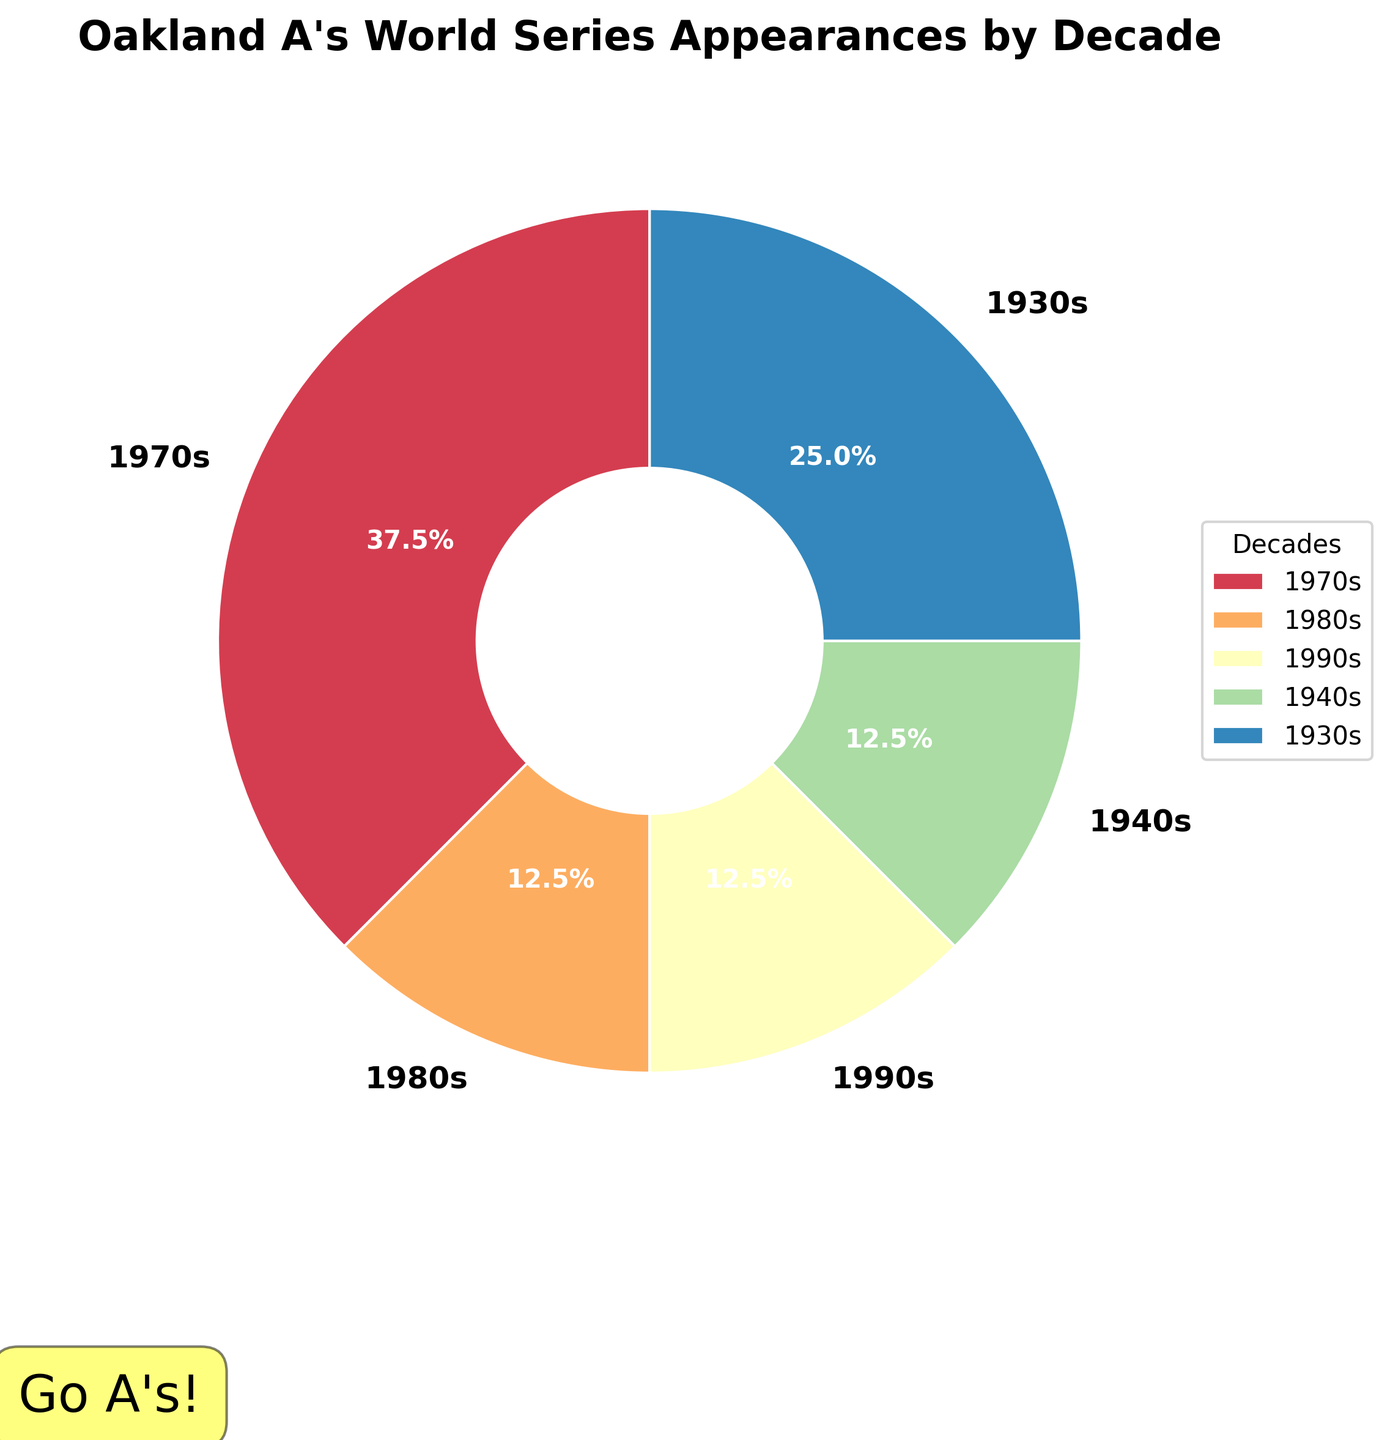Which decade had the highest number of World Series appearances? From the figure, the 1970s segment of the pie chart is the largest, indicating it had the highest number of appearances.
Answer: 1970s How many decades had zero World Series appearances? By looking at the labels, the chart only includes segments corresponding to decades with non-zero appearances. This means there are no segments for the 2000s, 2010s, 1960s, 1950s, 1920s, which are five decades.
Answer: 5 What percentage of the World Series appearances occurred in the 1970s? The pie chart shows the percentage values for each segment. The segment for the 1970s shows 42.9%, which means 42.9% of the World Series appearances occurred in the 1970s.
Answer: 42.9% Compare the number of World Series appearances in the 1930s to those in the 1940s. Which had more? From the chart, the 1930s had 2 appearances, while the 1940s had 1 appearance. Therefore, the 1930s had more appearances.
Answer: 1930s Which decade has the smallest segment in the chart? The smallest segment in the pie chart refers to the 1980s and 1990s, as they each only had 1 appearance. Visually, both segments are the same size, making them the smallest.
Answer: 1980s or 1990s What percentage of the appearances happened before the 1940s? Pre-1940s decades featured here are the 1930s with 2 appearances. The total appearances shown in the chart are 8 (sum of all segments: 3 + 1 + 1 + 1 + 2). The 1930s' 2 appearances out of 8 total appearances represent 25% (2/8 * 100).
Answer: 25% What is the combined percentage of the appearances from the 1980s and 1990s? The 1980s and 1990s each had 1 appearance. With a total of 8 appearances, they jointly represent 2 out of 8. This is 25% (2/8 * 100).
Answer: 25% How many total World Series appearances did the Oakland A's have according to the chart? The chart shows the appearances: 3 (1970s) + 1 (1980s) + 1 (1990s) + 1 (1940s) + 2 (1930s). Summing them gives 8 appearances.
Answer: 8 Which decades had an equal number of World Series appearances? Based on the chart, the 1980s and 1990s both had 1 appearance each, making them equal.
Answer: 1980s and 1990s 